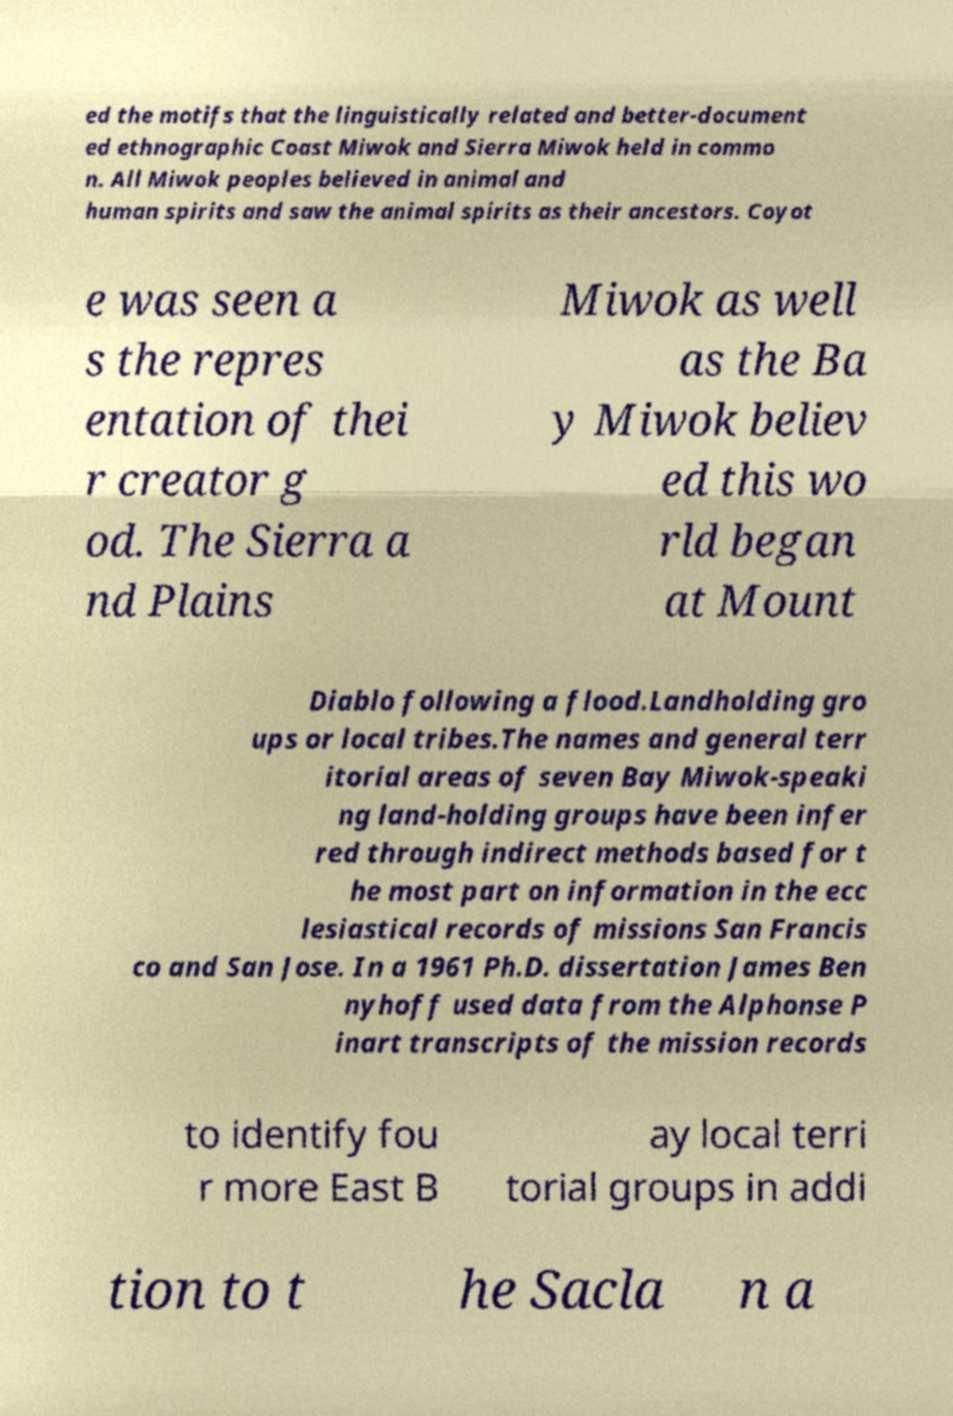Could you extract and type out the text from this image? ed the motifs that the linguistically related and better-document ed ethnographic Coast Miwok and Sierra Miwok held in commo n. All Miwok peoples believed in animal and human spirits and saw the animal spirits as their ancestors. Coyot e was seen a s the repres entation of thei r creator g od. The Sierra a nd Plains Miwok as well as the Ba y Miwok believ ed this wo rld began at Mount Diablo following a flood.Landholding gro ups or local tribes.The names and general terr itorial areas of seven Bay Miwok-speaki ng land-holding groups have been infer red through indirect methods based for t he most part on information in the ecc lesiastical records of missions San Francis co and San Jose. In a 1961 Ph.D. dissertation James Ben nyhoff used data from the Alphonse P inart transcripts of the mission records to identify fou r more East B ay local terri torial groups in addi tion to t he Sacla n a 